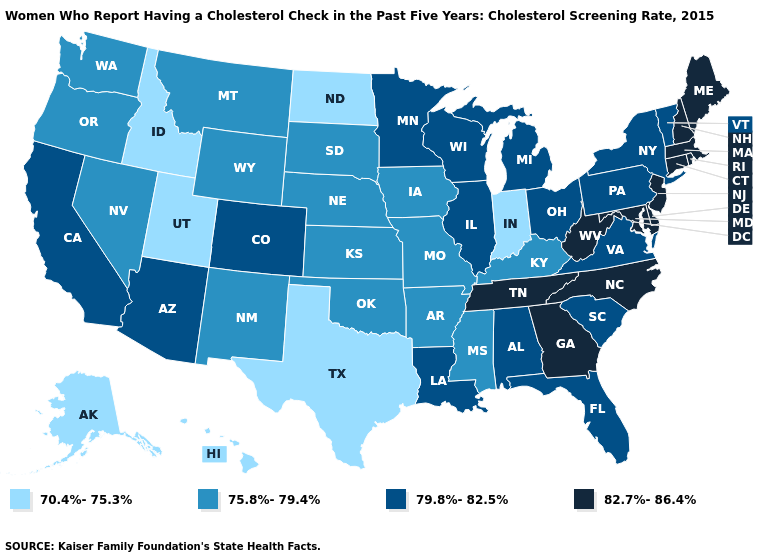Does Mississippi have the lowest value in the USA?
Quick response, please. No. Among the states that border Montana , does Idaho have the highest value?
Be succinct. No. Name the states that have a value in the range 70.4%-75.3%?
Answer briefly. Alaska, Hawaii, Idaho, Indiana, North Dakota, Texas, Utah. Does Massachusetts have the lowest value in the Northeast?
Keep it brief. No. Does Alaska have a higher value than Louisiana?
Concise answer only. No. Name the states that have a value in the range 75.8%-79.4%?
Keep it brief. Arkansas, Iowa, Kansas, Kentucky, Mississippi, Missouri, Montana, Nebraska, Nevada, New Mexico, Oklahoma, Oregon, South Dakota, Washington, Wyoming. What is the value of Louisiana?
Keep it brief. 79.8%-82.5%. Does Oklahoma have the same value as Georgia?
Keep it brief. No. Which states hav the highest value in the MidWest?
Answer briefly. Illinois, Michigan, Minnesota, Ohio, Wisconsin. Name the states that have a value in the range 75.8%-79.4%?
Short answer required. Arkansas, Iowa, Kansas, Kentucky, Mississippi, Missouri, Montana, Nebraska, Nevada, New Mexico, Oklahoma, Oregon, South Dakota, Washington, Wyoming. Does Minnesota have the lowest value in the MidWest?
Give a very brief answer. No. Among the states that border Arizona , which have the highest value?
Give a very brief answer. California, Colorado. Name the states that have a value in the range 79.8%-82.5%?
Answer briefly. Alabama, Arizona, California, Colorado, Florida, Illinois, Louisiana, Michigan, Minnesota, New York, Ohio, Pennsylvania, South Carolina, Vermont, Virginia, Wisconsin. What is the value of South Carolina?
Give a very brief answer. 79.8%-82.5%. Name the states that have a value in the range 79.8%-82.5%?
Be succinct. Alabama, Arizona, California, Colorado, Florida, Illinois, Louisiana, Michigan, Minnesota, New York, Ohio, Pennsylvania, South Carolina, Vermont, Virginia, Wisconsin. 